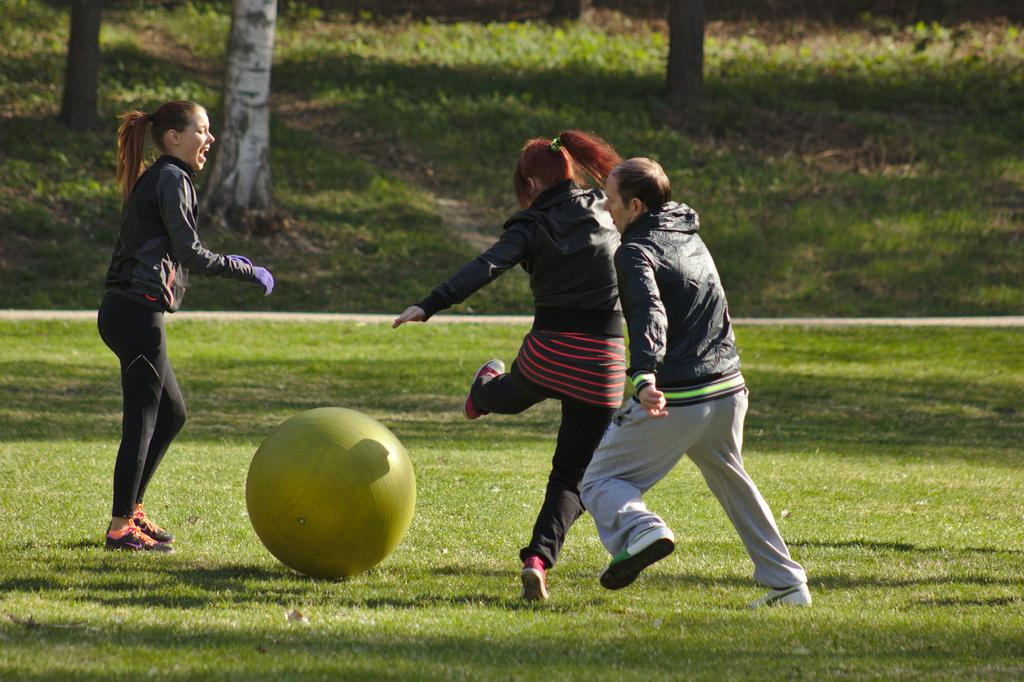What are the persons in the image doing? The persons in the image are playing with an exercise ball. What type of surface is visible in the image? There is grass visible in the image. What type of man-made structure can be seen in the image? There is a road in the image. What natural object is present in the image? There is a trunk (possibly a tree trunk) in the image. What type of home can be seen in the background of the image? There is no home visible in the image. How many cattle are present in the image? There are no cattle present in the image. 